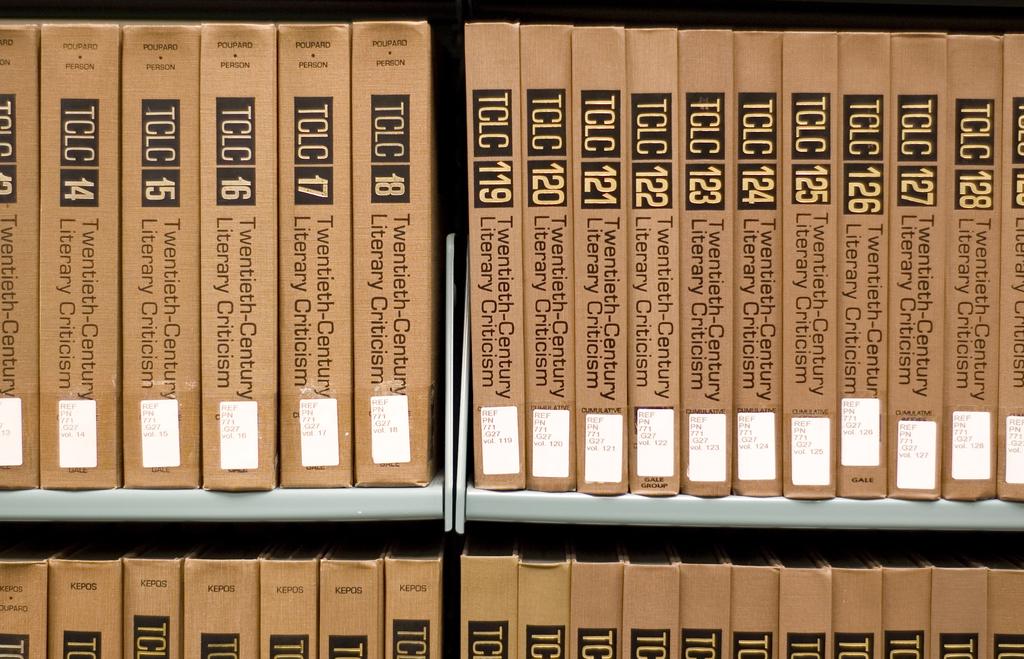What is a number on any book?
Your answer should be very brief. 119. 